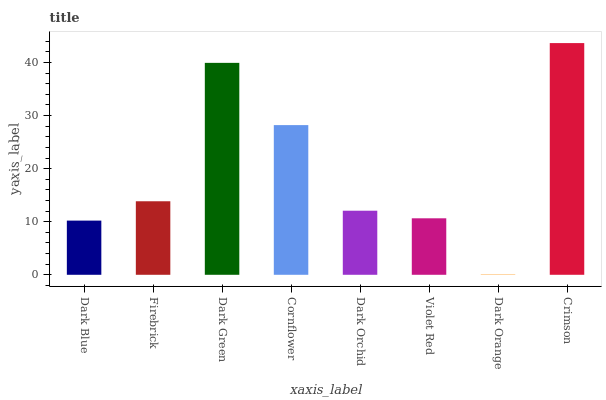Is Dark Orange the minimum?
Answer yes or no. Yes. Is Crimson the maximum?
Answer yes or no. Yes. Is Firebrick the minimum?
Answer yes or no. No. Is Firebrick the maximum?
Answer yes or no. No. Is Firebrick greater than Dark Blue?
Answer yes or no. Yes. Is Dark Blue less than Firebrick?
Answer yes or no. Yes. Is Dark Blue greater than Firebrick?
Answer yes or no. No. Is Firebrick less than Dark Blue?
Answer yes or no. No. Is Firebrick the high median?
Answer yes or no. Yes. Is Dark Orchid the low median?
Answer yes or no. Yes. Is Cornflower the high median?
Answer yes or no. No. Is Violet Red the low median?
Answer yes or no. No. 